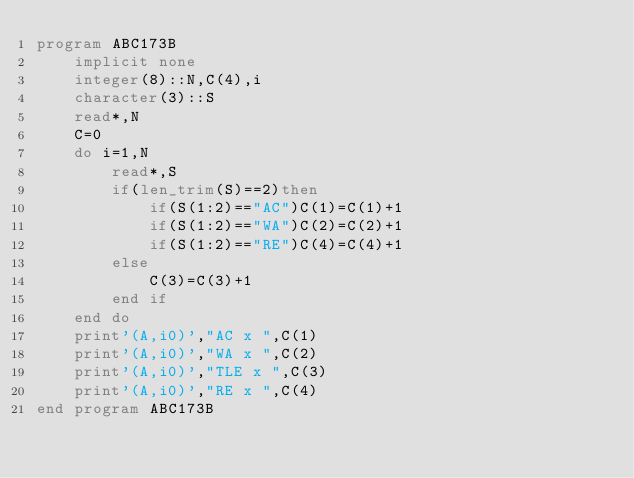<code> <loc_0><loc_0><loc_500><loc_500><_FORTRAN_>program ABC173B
    implicit none
    integer(8)::N,C(4),i
    character(3)::S
    read*,N
    C=0
    do i=1,N
        read*,S
        if(len_trim(S)==2)then
            if(S(1:2)=="AC")C(1)=C(1)+1
            if(S(1:2)=="WA")C(2)=C(2)+1
            if(S(1:2)=="RE")C(4)=C(4)+1
        else
            C(3)=C(3)+1
        end if
    end do
    print'(A,i0)',"AC x ",C(1)
    print'(A,i0)',"WA x ",C(2)
    print'(A,i0)',"TLE x ",C(3)
    print'(A,i0)',"RE x ",C(4)
end program ABC173B</code> 